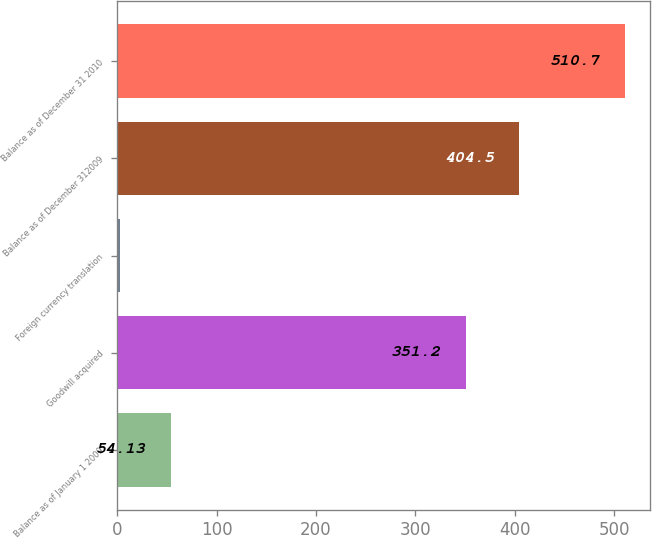Convert chart to OTSL. <chart><loc_0><loc_0><loc_500><loc_500><bar_chart><fcel>Balance as of January 1 2009<fcel>Goodwill acquired<fcel>Foreign currency translation<fcel>Balance as of December 312009<fcel>Balance as of December 31 2010<nl><fcel>54.13<fcel>351.2<fcel>3.4<fcel>404.5<fcel>510.7<nl></chart> 